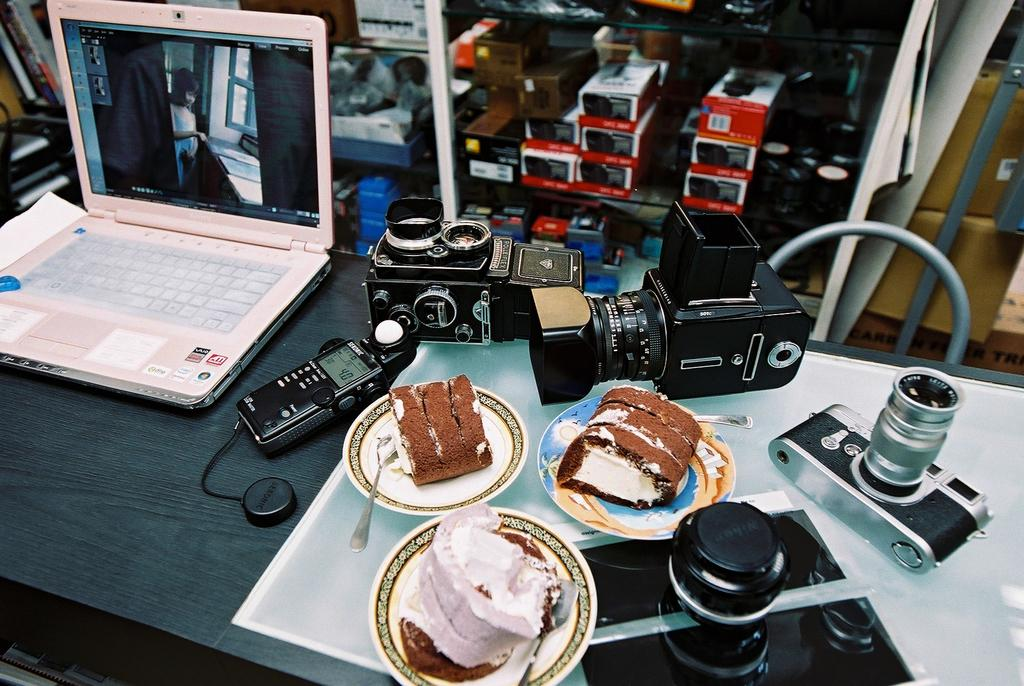What electronic device is on the table in the image? There is a laptop on the table in the image. What other object related to communication can be seen on the table? There is a telephone on the table. What type of equipment is used for capturing images on the table? There are cameras on the table. What type of food is on the table? There is a plate of pastries on the table. What utensil is on the table? There is a spoon on the table. What type of creature is using the hose to water the plants in the image? There is no creature or hose present in the image; it only features a laptop, telephone, cameras, pastries, and a spoon on a table. 